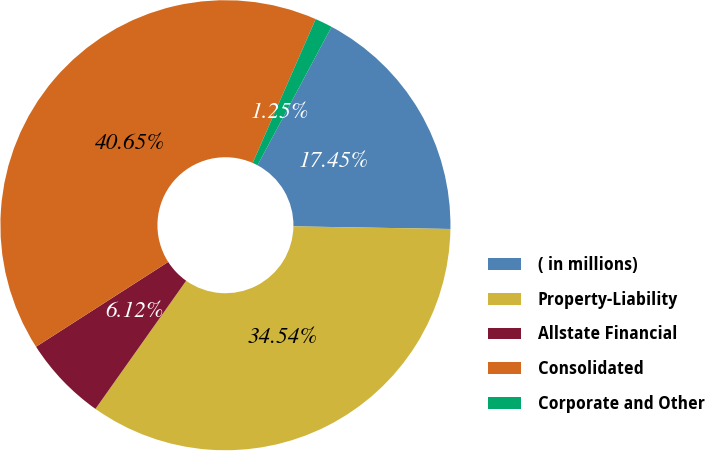Convert chart. <chart><loc_0><loc_0><loc_500><loc_500><pie_chart><fcel>( in millions)<fcel>Property-Liability<fcel>Allstate Financial<fcel>Consolidated<fcel>Corporate and Other<nl><fcel>17.45%<fcel>34.54%<fcel>6.12%<fcel>40.65%<fcel>1.25%<nl></chart> 